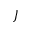<formula> <loc_0><loc_0><loc_500><loc_500>J</formula> 